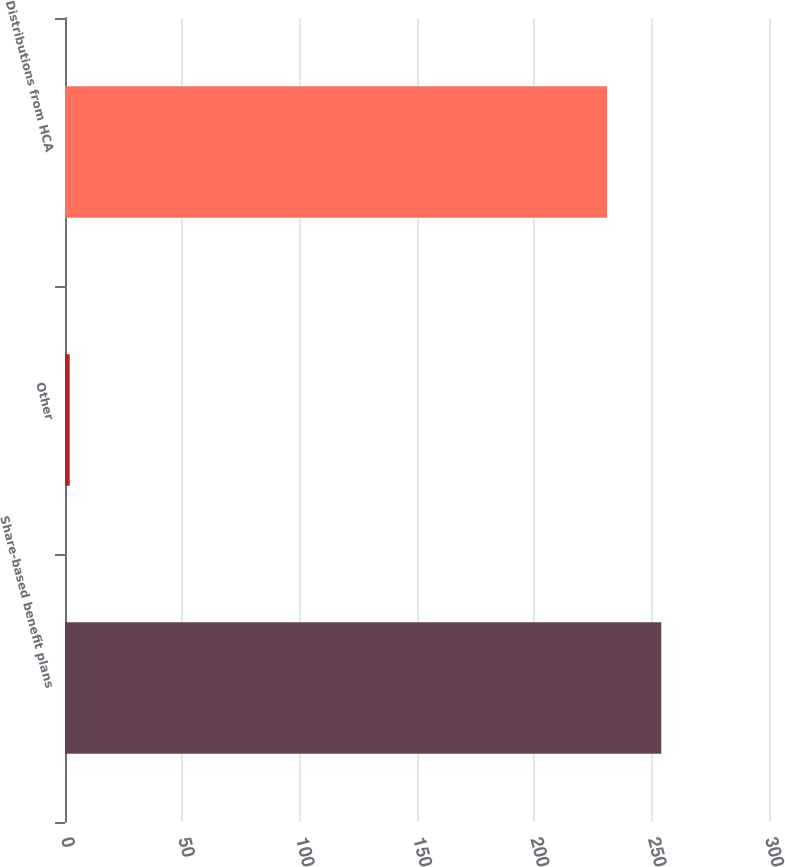Convert chart. <chart><loc_0><loc_0><loc_500><loc_500><bar_chart><fcel>Share-based benefit plans<fcel>Other<fcel>Distributions from HCA<nl><fcel>254.1<fcel>2<fcel>231<nl></chart> 